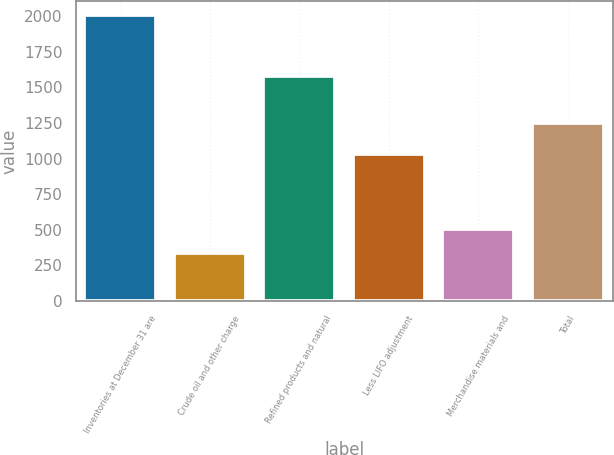Convert chart. <chart><loc_0><loc_0><loc_500><loc_500><bar_chart><fcel>Inventories at December 31 are<fcel>Crude oil and other charge<fcel>Refined products and natural<fcel>Less LIFO adjustment<fcel>Merchandise materials and<fcel>Total<nl><fcel>2007<fcel>338<fcel>1577<fcel>1029<fcel>504.9<fcel>1250<nl></chart> 